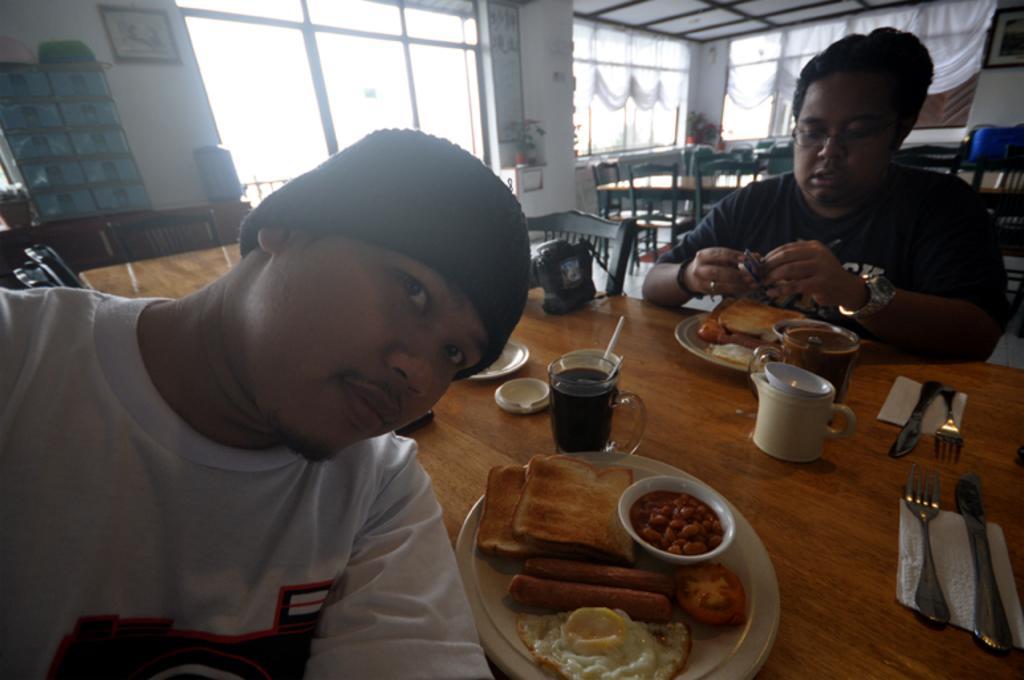How would you summarize this image in a sentence or two? In this picture, there are two persons sitting in the chairs in front of a table. On the table there is some food on in the plate. We can observe fork, knife, tissues and some cups and glasses here. In the background there is a curtains, windows and a wall here. 